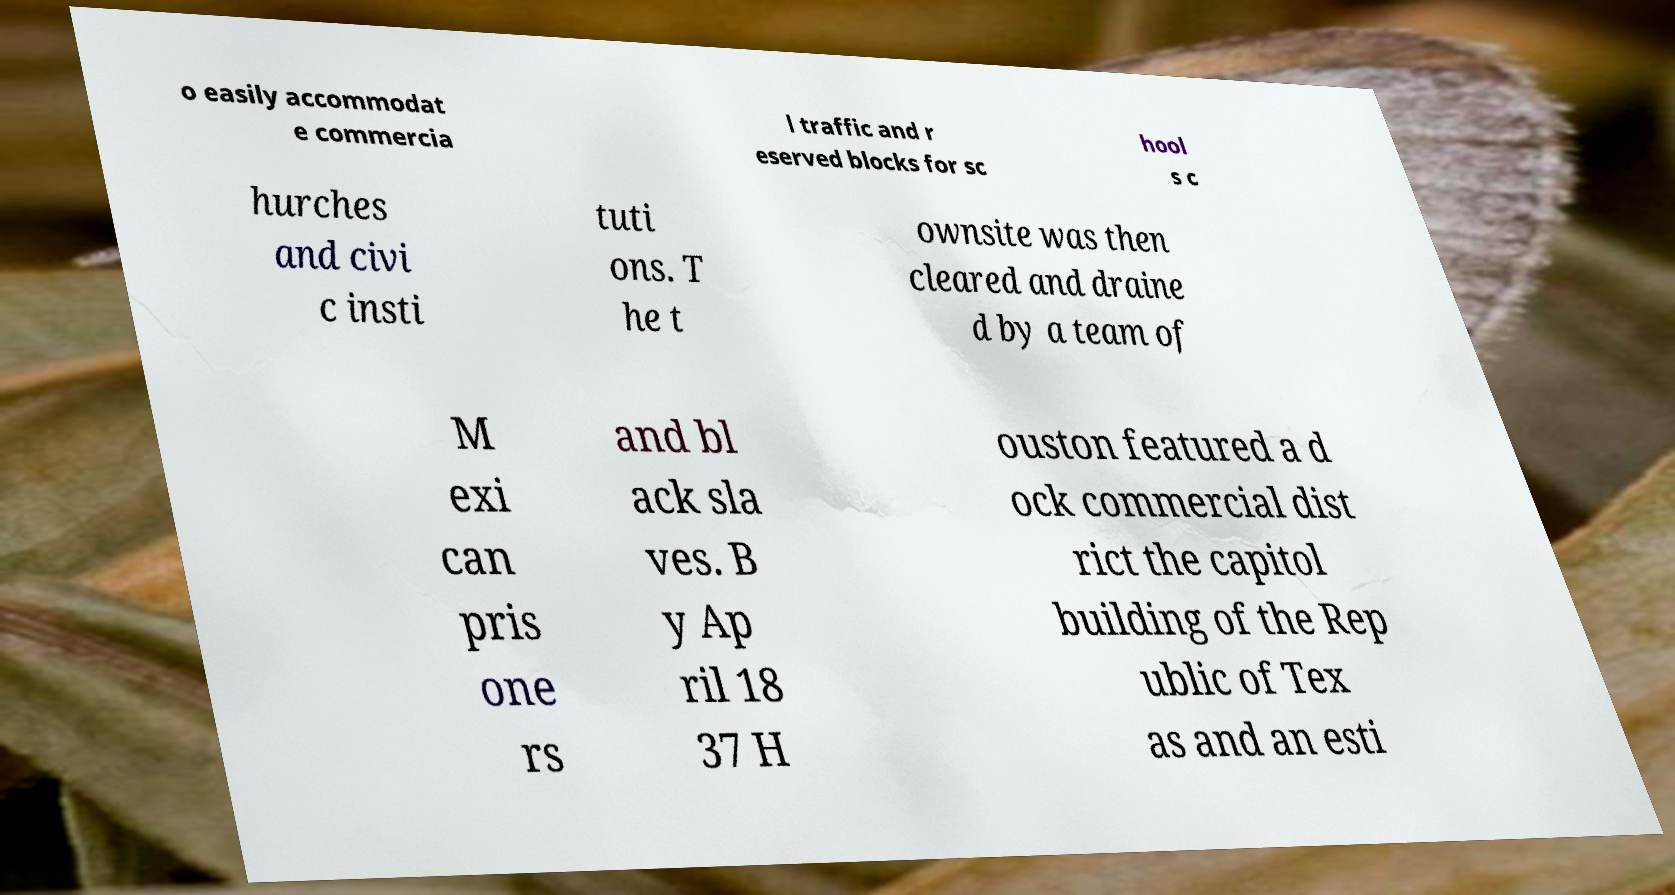Could you assist in decoding the text presented in this image and type it out clearly? o easily accommodat e commercia l traffic and r eserved blocks for sc hool s c hurches and civi c insti tuti ons. T he t ownsite was then cleared and draine d by a team of M exi can pris one rs and bl ack sla ves. B y Ap ril 18 37 H ouston featured a d ock commercial dist rict the capitol building of the Rep ublic of Tex as and an esti 